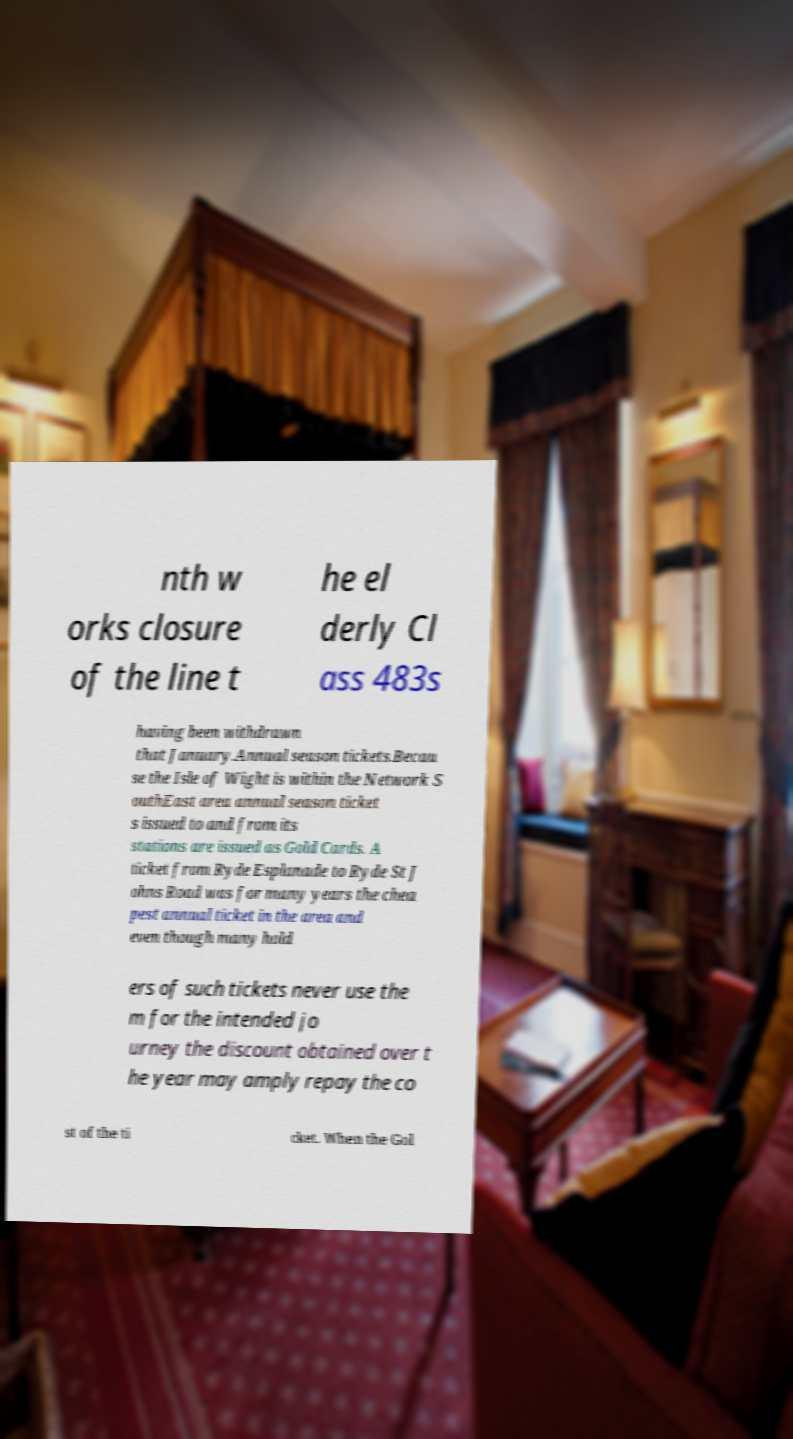I need the written content from this picture converted into text. Can you do that? nth w orks closure of the line t he el derly Cl ass 483s having been withdrawn that January.Annual season tickets.Becau se the Isle of Wight is within the Network S outhEast area annual season ticket s issued to and from its stations are issued as Gold Cards. A ticket from Ryde Esplanade to Ryde St J ohns Road was for many years the chea pest annual ticket in the area and even though many hold ers of such tickets never use the m for the intended jo urney the discount obtained over t he year may amply repay the co st of the ti cket. When the Gol 